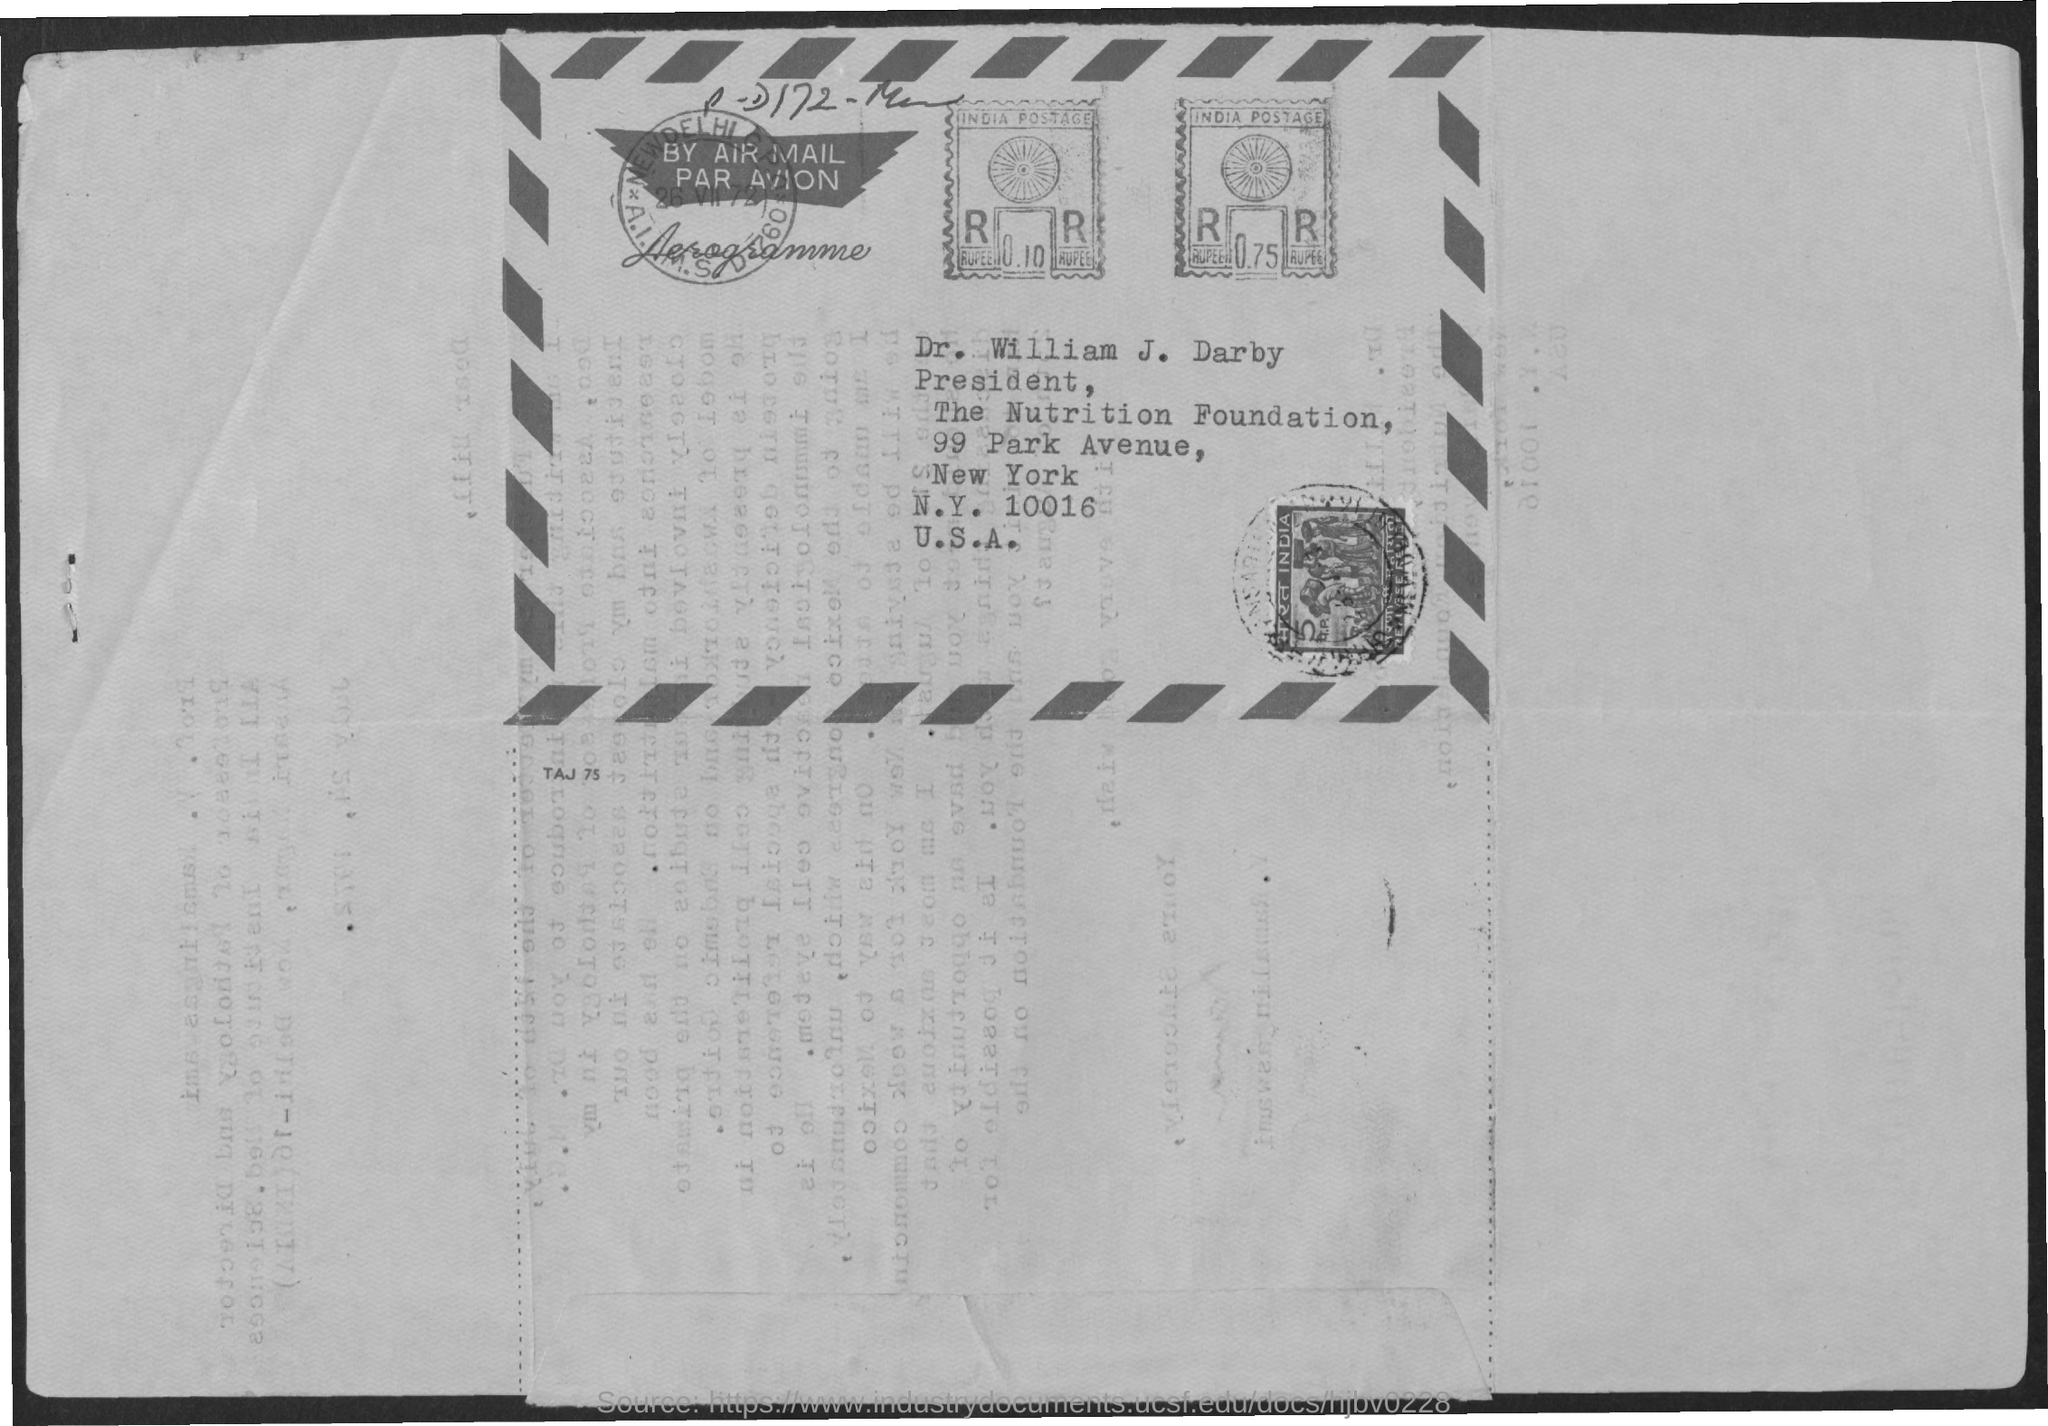Highlight a few significant elements in this photo. I am looking for a zip code that is mentioned, specifically 10016. The name of the person whose mention is requested is Dr. William J. Darby. The postage stamp in question is from India. Dr. William J. Darby is known as the president. The street address mentioned is 99 Park Avenue. 